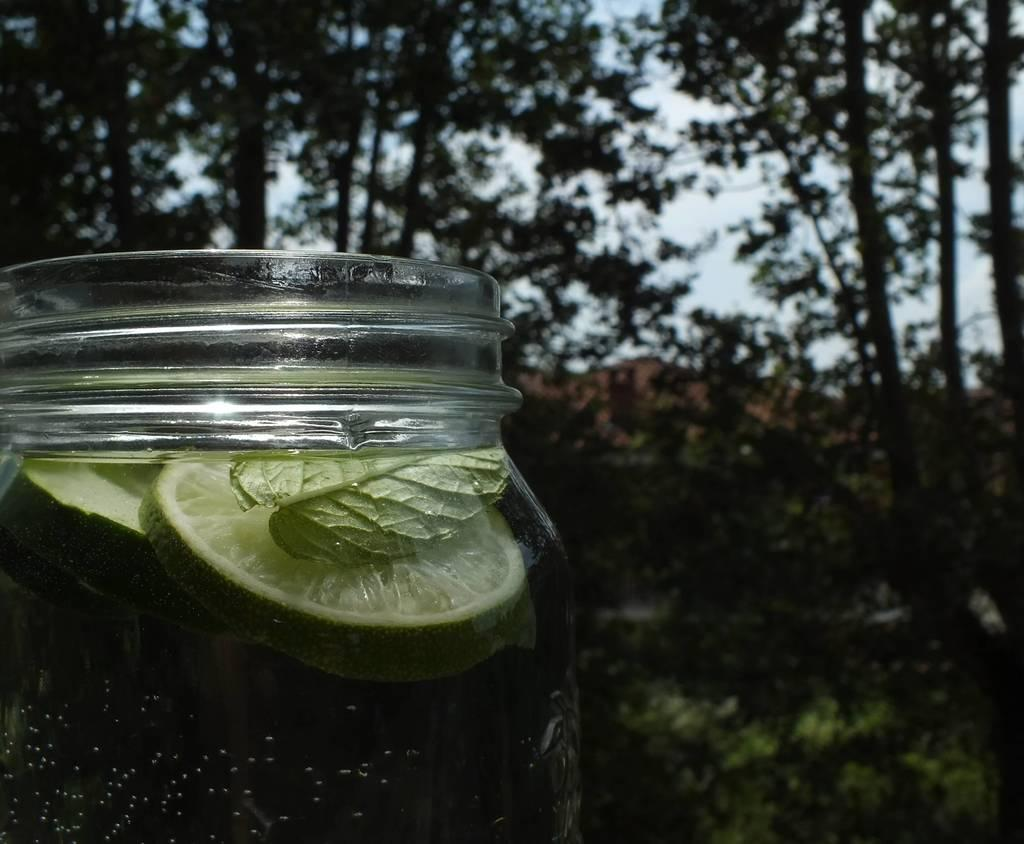What type of container is present in the image? There is a glass container in the image. What can be found inside the glass container? There are objects inside the glass container. What type of natural scenery is visible in the image? Trees are visible in the image. What part of the natural environment is visible in the image? The sky is visible in the image. How much money is being transported in the carriage in the image? There is no carriage present in the image, and therefore no money transportation can be observed. 